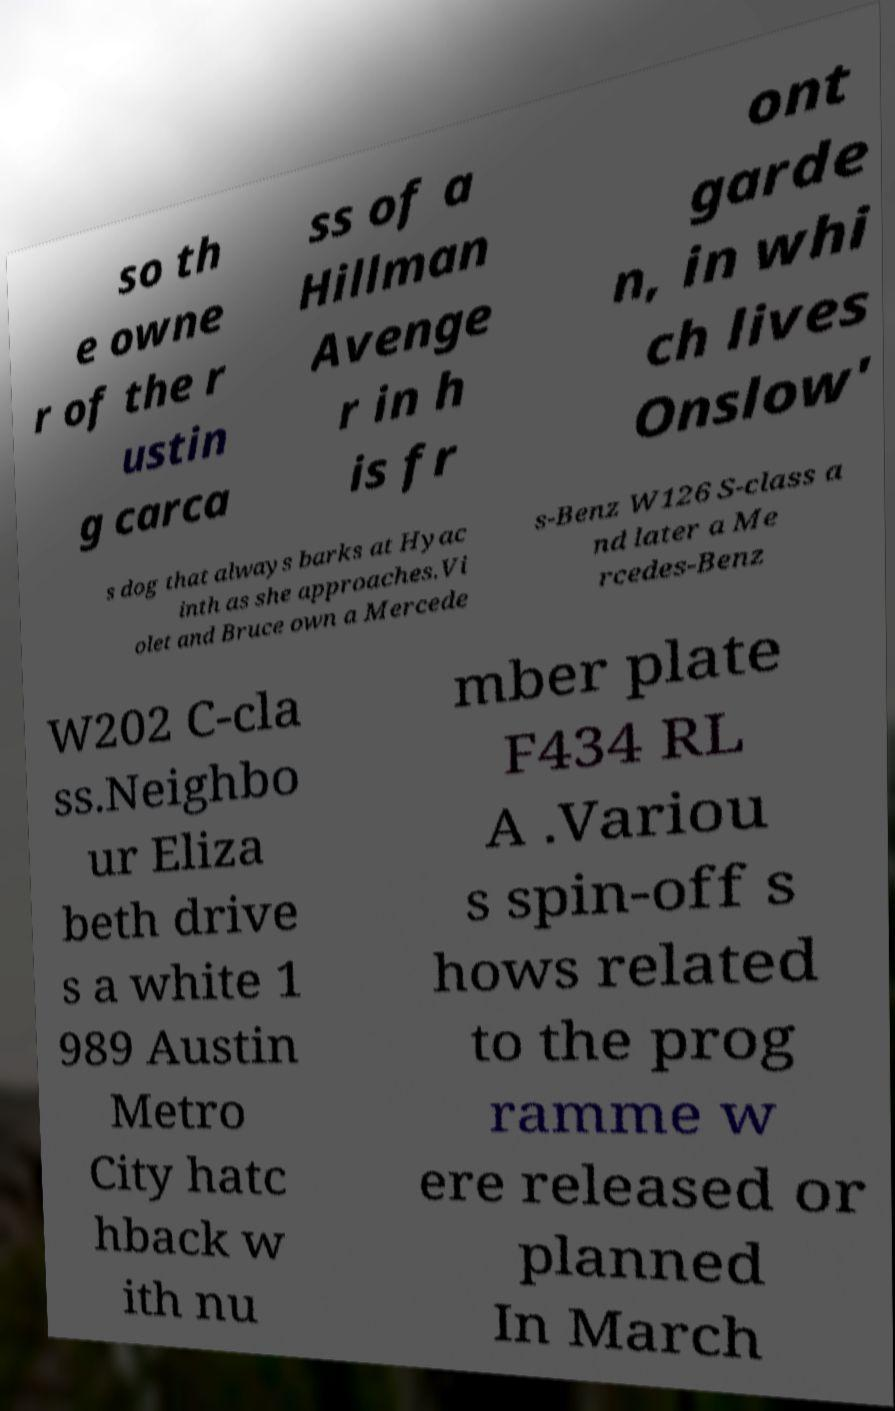Please identify and transcribe the text found in this image. so th e owne r of the r ustin g carca ss of a Hillman Avenge r in h is fr ont garde n, in whi ch lives Onslow' s dog that always barks at Hyac inth as she approaches.Vi olet and Bruce own a Mercede s-Benz W126 S-class a nd later a Me rcedes-Benz W202 C-cla ss.Neighbo ur Eliza beth drive s a white 1 989 Austin Metro City hatc hback w ith nu mber plate F434 RL A .Variou s spin-off s hows related to the prog ramme w ere released or planned In March 